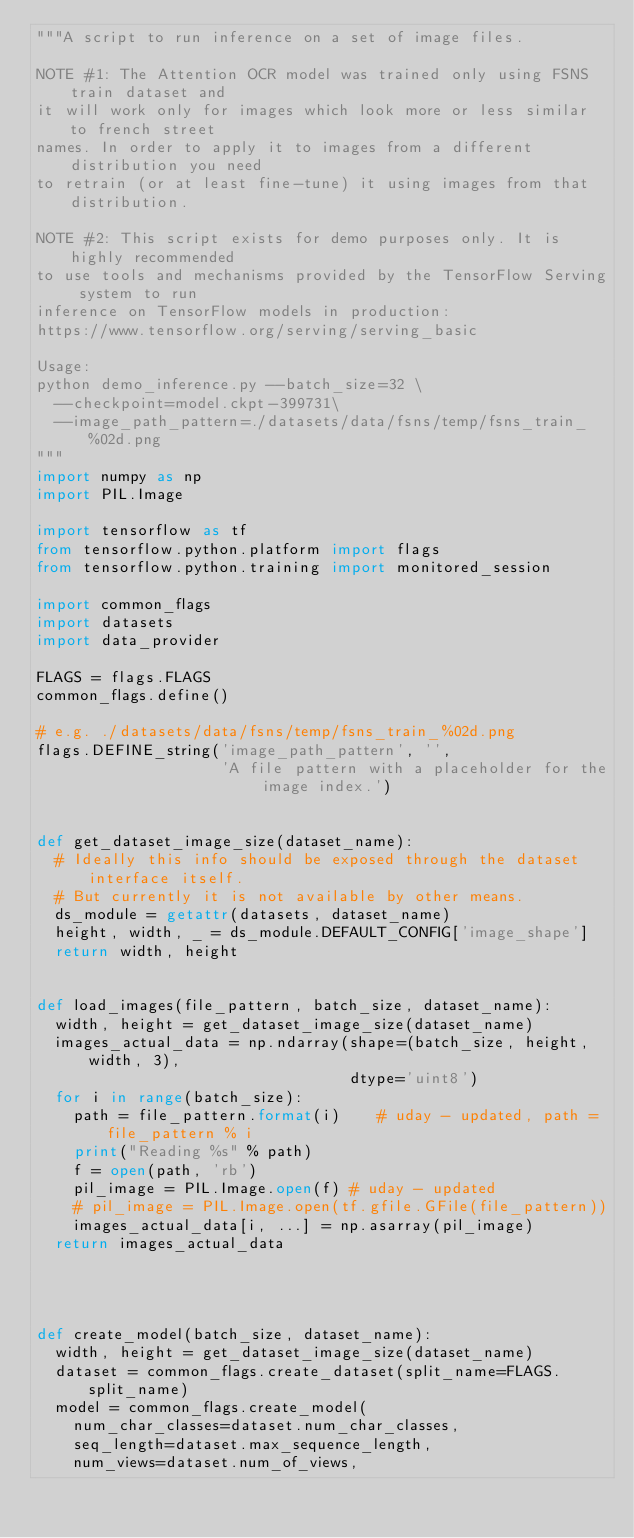Convert code to text. <code><loc_0><loc_0><loc_500><loc_500><_Python_>"""A script to run inference on a set of image files.

NOTE #1: The Attention OCR model was trained only using FSNS train dataset and
it will work only for images which look more or less similar to french street
names. In order to apply it to images from a different distribution you need
to retrain (or at least fine-tune) it using images from that distribution.

NOTE #2: This script exists for demo purposes only. It is highly recommended
to use tools and mechanisms provided by the TensorFlow Serving system to run
inference on TensorFlow models in production:
https://www.tensorflow.org/serving/serving_basic

Usage:
python demo_inference.py --batch_size=32 \
  --checkpoint=model.ckpt-399731\
  --image_path_pattern=./datasets/data/fsns/temp/fsns_train_%02d.png
"""
import numpy as np
import PIL.Image

import tensorflow as tf
from tensorflow.python.platform import flags
from tensorflow.python.training import monitored_session

import common_flags
import datasets
import data_provider

FLAGS = flags.FLAGS
common_flags.define()

# e.g. ./datasets/data/fsns/temp/fsns_train_%02d.png
flags.DEFINE_string('image_path_pattern', '',
                    'A file pattern with a placeholder for the image index.')


def get_dataset_image_size(dataset_name):
  # Ideally this info should be exposed through the dataset interface itself.
  # But currently it is not available by other means.
  ds_module = getattr(datasets, dataset_name)
  height, width, _ = ds_module.DEFAULT_CONFIG['image_shape']
  return width, height


def load_images(file_pattern, batch_size, dataset_name):
  width, height = get_dataset_image_size(dataset_name)
  images_actual_data = np.ndarray(shape=(batch_size, height, width, 3),
                                  dtype='uint8')
  for i in range(batch_size):
    path = file_pattern.format(i)    # uday - updated, path = file_pattern % i
    print("Reading %s" % path)
    f = open(path, 'rb')
    pil_image = PIL.Image.open(f) # uday - updated
    # pil_image = PIL.Image.open(tf.gfile.GFile(file_pattern))
    images_actual_data[i, ...] = np.asarray(pil_image)
  return images_actual_data

  


def create_model(batch_size, dataset_name):
  width, height = get_dataset_image_size(dataset_name)
  dataset = common_flags.create_dataset(split_name=FLAGS.split_name)
  model = common_flags.create_model(
    num_char_classes=dataset.num_char_classes,
    seq_length=dataset.max_sequence_length,
    num_views=dataset.num_of_views,</code> 